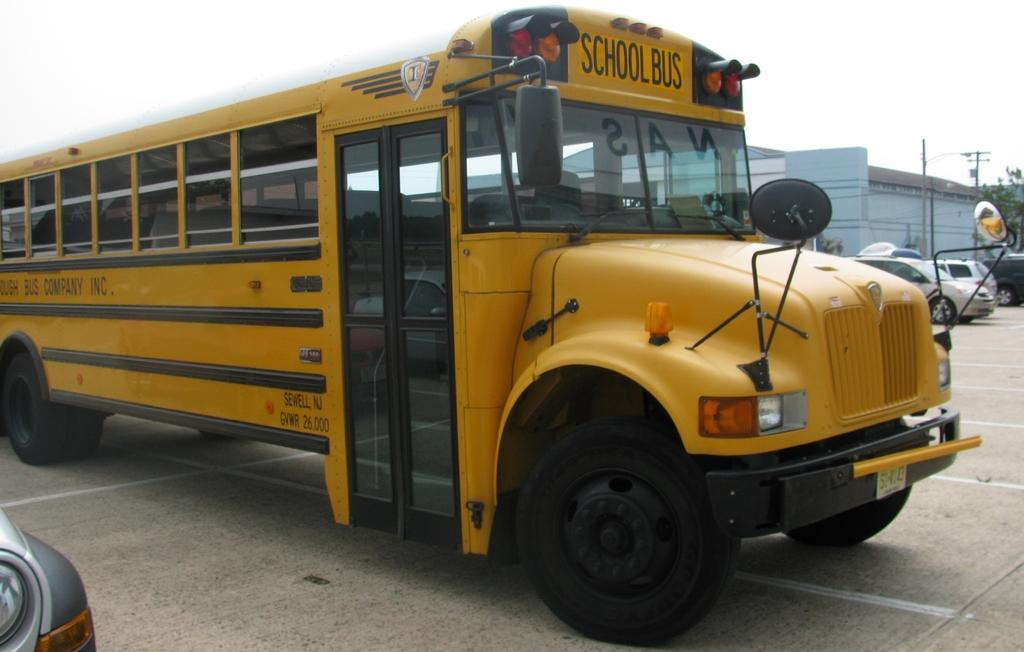What can be seen on the road in the image? There are vehicles on the road in the image. What is visible in the background of the image? There is a building and poles in the background of the image. What part of the natural environment is visible in the image? The sky is visible in the background of the image. Can you tell me how many rabbits are visible in the image? There are no rabbits present in the image. What type of group is shown interacting with the vehicles on the road? There is no group shown interacting with the vehicles on the road; only the vehicles are present. 